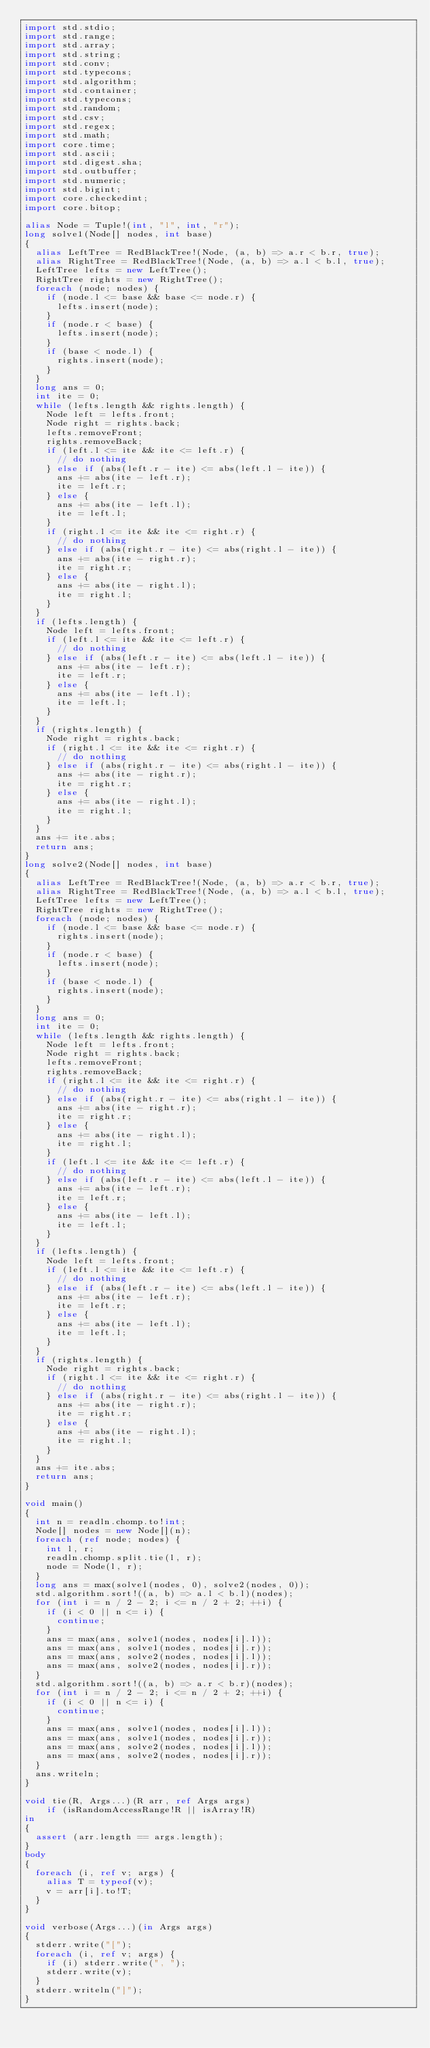Convert code to text. <code><loc_0><loc_0><loc_500><loc_500><_D_>import std.stdio;
import std.range;
import std.array;
import std.string;
import std.conv;
import std.typecons;
import std.algorithm;
import std.container;
import std.typecons;
import std.random;
import std.csv;
import std.regex;
import std.math;
import core.time;
import std.ascii;
import std.digest.sha;
import std.outbuffer;
import std.numeric;
import std.bigint;
import core.checkedint;
import core.bitop;

alias Node = Tuple!(int, "l", int, "r");
long solve1(Node[] nodes, int base)
{
	alias LeftTree = RedBlackTree!(Node, (a, b) => a.r < b.r, true);
	alias RightTree = RedBlackTree!(Node, (a, b) => a.l < b.l, true);
	LeftTree lefts = new LeftTree();
	RightTree rights = new RightTree();
	foreach (node; nodes) {
		if (node.l <= base && base <= node.r) {
			lefts.insert(node);
		}
		if (node.r < base) {
			lefts.insert(node);
		}
		if (base < node.l) {
			rights.insert(node);
		}
	}
	long ans = 0;
	int ite = 0;
	while (lefts.length && rights.length) {
		Node left = lefts.front;
		Node right = rights.back;
		lefts.removeFront;
		rights.removeBack;
		if (left.l <= ite && ite <= left.r) {
			// do nothing
		} else if (abs(left.r - ite) <= abs(left.l - ite)) {
			ans += abs(ite - left.r);
			ite = left.r;
		} else {
			ans += abs(ite - left.l);
			ite = left.l;
		}
		if (right.l <= ite && ite <= right.r) {
			// do nothing
		} else if (abs(right.r - ite) <= abs(right.l - ite)) {
			ans += abs(ite - right.r);
			ite = right.r;
		} else {
			ans += abs(ite - right.l);
			ite = right.l;
		}
	}
	if (lefts.length) {
		Node left = lefts.front;
		if (left.l <= ite && ite <= left.r) {
			// do nothing
		} else if (abs(left.r - ite) <= abs(left.l - ite)) {
			ans += abs(ite - left.r);
			ite = left.r;
		} else {
			ans += abs(ite - left.l);
			ite = left.l;
		}
	}
	if (rights.length) {
		Node right = rights.back;
		if (right.l <= ite && ite <= right.r) {
			// do nothing
		} else if (abs(right.r - ite) <= abs(right.l - ite)) {
			ans += abs(ite - right.r);
			ite = right.r;
		} else {
			ans += abs(ite - right.l);
			ite = right.l;
		}
	}
	ans += ite.abs;
	return ans;
}
long solve2(Node[] nodes, int base)
{
	alias LeftTree = RedBlackTree!(Node, (a, b) => a.r < b.r, true);
	alias RightTree = RedBlackTree!(Node, (a, b) => a.l < b.l, true);
	LeftTree lefts = new LeftTree();
	RightTree rights = new RightTree();
	foreach (node; nodes) {
		if (node.l <= base && base <= node.r) {
			rights.insert(node);
		}
		if (node.r < base) {
			lefts.insert(node);
		}
		if (base < node.l) {
			rights.insert(node);
		}
	}
	long ans = 0;
	int ite = 0;
	while (lefts.length && rights.length) {
		Node left = lefts.front;
		Node right = rights.back;
		lefts.removeFront;
		rights.removeBack;
		if (right.l <= ite && ite <= right.r) {
			// do nothing
		} else if (abs(right.r - ite) <= abs(right.l - ite)) {
			ans += abs(ite - right.r);
			ite = right.r;
		} else {
			ans += abs(ite - right.l);
			ite = right.l;
		}
		if (left.l <= ite && ite <= left.r) {
			// do nothing
		} else if (abs(left.r - ite) <= abs(left.l - ite)) {
			ans += abs(ite - left.r);
			ite = left.r;
		} else {
			ans += abs(ite - left.l);
			ite = left.l;
		}
	}
	if (lefts.length) {
		Node left = lefts.front;
		if (left.l <= ite && ite <= left.r) {
			// do nothing
		} else if (abs(left.r - ite) <= abs(left.l - ite)) {
			ans += abs(ite - left.r);
			ite = left.r;
		} else {
			ans += abs(ite - left.l);
			ite = left.l;
		}
	}
	if (rights.length) {
		Node right = rights.back;
		if (right.l <= ite && ite <= right.r) {
			// do nothing
		} else if (abs(right.r - ite) <= abs(right.l - ite)) {
			ans += abs(ite - right.r);
			ite = right.r;
		} else {
			ans += abs(ite - right.l);
			ite = right.l;
		}
	}
	ans += ite.abs;
	return ans;
}

void main()
{
	int n = readln.chomp.to!int;
	Node[] nodes = new Node[](n);
	foreach (ref node; nodes) {
		int l, r;
		readln.chomp.split.tie(l, r);
		node = Node(l, r);
	}
	long ans = max(solve1(nodes, 0), solve2(nodes, 0));
	std.algorithm.sort!((a, b) => a.l < b.l)(nodes);
	for (int i = n / 2 - 2; i <= n / 2 + 2; ++i) {
		if (i < 0 || n <= i) {
			continue;
		}
		ans = max(ans, solve1(nodes, nodes[i].l));
		ans = max(ans, solve1(nodes, nodes[i].r));
		ans = max(ans, solve2(nodes, nodes[i].l));
		ans = max(ans, solve2(nodes, nodes[i].r));
	}
	std.algorithm.sort!((a, b) => a.r < b.r)(nodes);
	for (int i = n / 2 - 2; i <= n / 2 + 2; ++i) {
		if (i < 0 || n <= i) {
			continue;
		}
		ans = max(ans, solve1(nodes, nodes[i].l));
		ans = max(ans, solve1(nodes, nodes[i].r));
		ans = max(ans, solve2(nodes, nodes[i].l));
		ans = max(ans, solve2(nodes, nodes[i].r));
	}
	ans.writeln;
}

void tie(R, Args...)(R arr, ref Args args)
		if (isRandomAccessRange!R || isArray!R)
in
{
	assert (arr.length == args.length);
}
body
{
	foreach (i, ref v; args) {
		alias T = typeof(v);
		v = arr[i].to!T;
	}
}

void verbose(Args...)(in Args args)
{
	stderr.write("[");
	foreach (i, ref v; args) {
		if (i) stderr.write(", ");
		stderr.write(v);
	}
	stderr.writeln("]");
}
</code> 